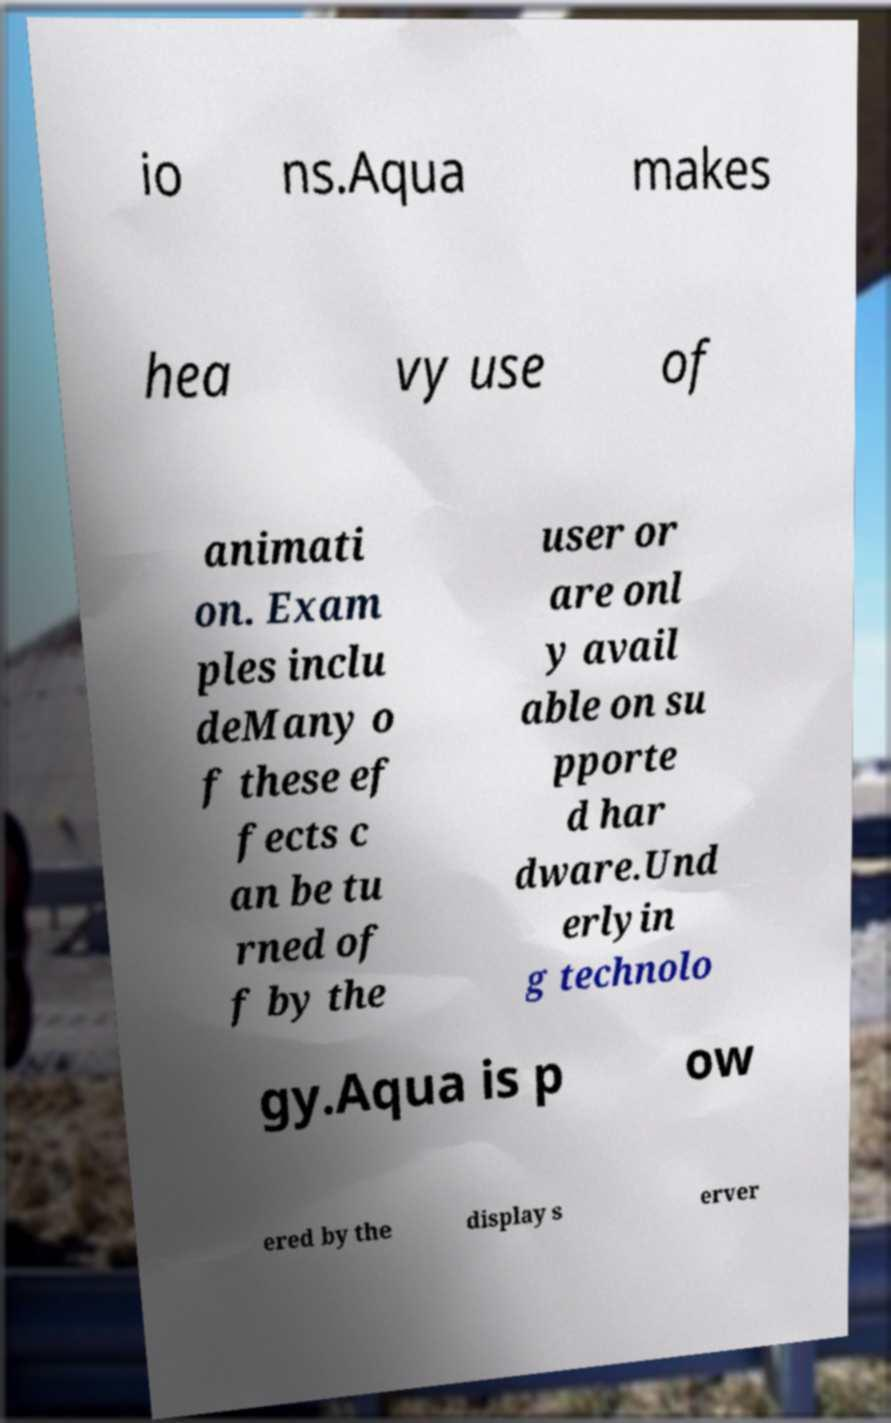Could you assist in decoding the text presented in this image and type it out clearly? io ns.Aqua makes hea vy use of animati on. Exam ples inclu deMany o f these ef fects c an be tu rned of f by the user or are onl y avail able on su pporte d har dware.Und erlyin g technolo gy.Aqua is p ow ered by the display s erver 